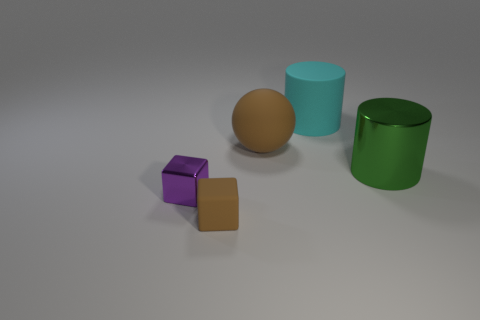Add 5 red objects. How many objects exist? 10 Subtract all cylinders. How many objects are left? 3 Subtract 1 brown cubes. How many objects are left? 4 Subtract all big gray matte spheres. Subtract all green cylinders. How many objects are left? 4 Add 3 rubber spheres. How many rubber spheres are left? 4 Add 4 small purple objects. How many small purple objects exist? 5 